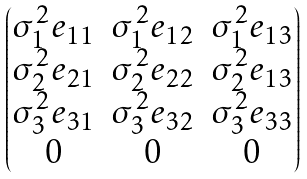Convert formula to latex. <formula><loc_0><loc_0><loc_500><loc_500>\begin{pmatrix} \sigma _ { 1 } ^ { 2 } e _ { 1 1 } & \sigma _ { 1 } ^ { 2 } e _ { 1 2 } & \sigma _ { 1 } ^ { 2 } e _ { 1 3 } \\ \sigma _ { 2 } ^ { 2 } e _ { 2 1 } & \sigma _ { 2 } ^ { 2 } e _ { 2 2 } & \sigma _ { 2 } ^ { 2 } e _ { 1 3 } \\ \sigma _ { 3 } ^ { 2 } e _ { 3 1 } & \sigma _ { 3 } ^ { 2 } e _ { 3 2 } & \sigma _ { 3 } ^ { 2 } e _ { 3 3 } \\ 0 & 0 & 0 \end{pmatrix}</formula> 